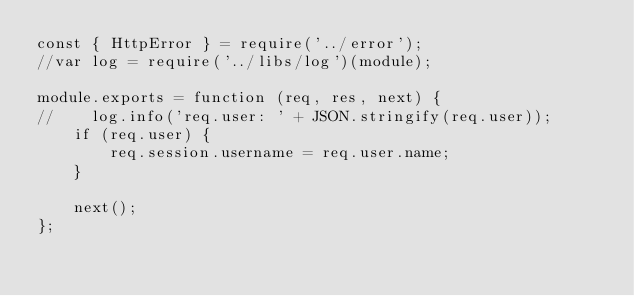<code> <loc_0><loc_0><loc_500><loc_500><_JavaScript_>const { HttpError } = require('../error');
//var log = require('../libs/log')(module);

module.exports = function (req, res, next) {
//    log.info('req.user: ' + JSON.stringify(req.user));
    if (req.user) {
        req.session.username = req.user.name;
    }

    next();
};
</code> 